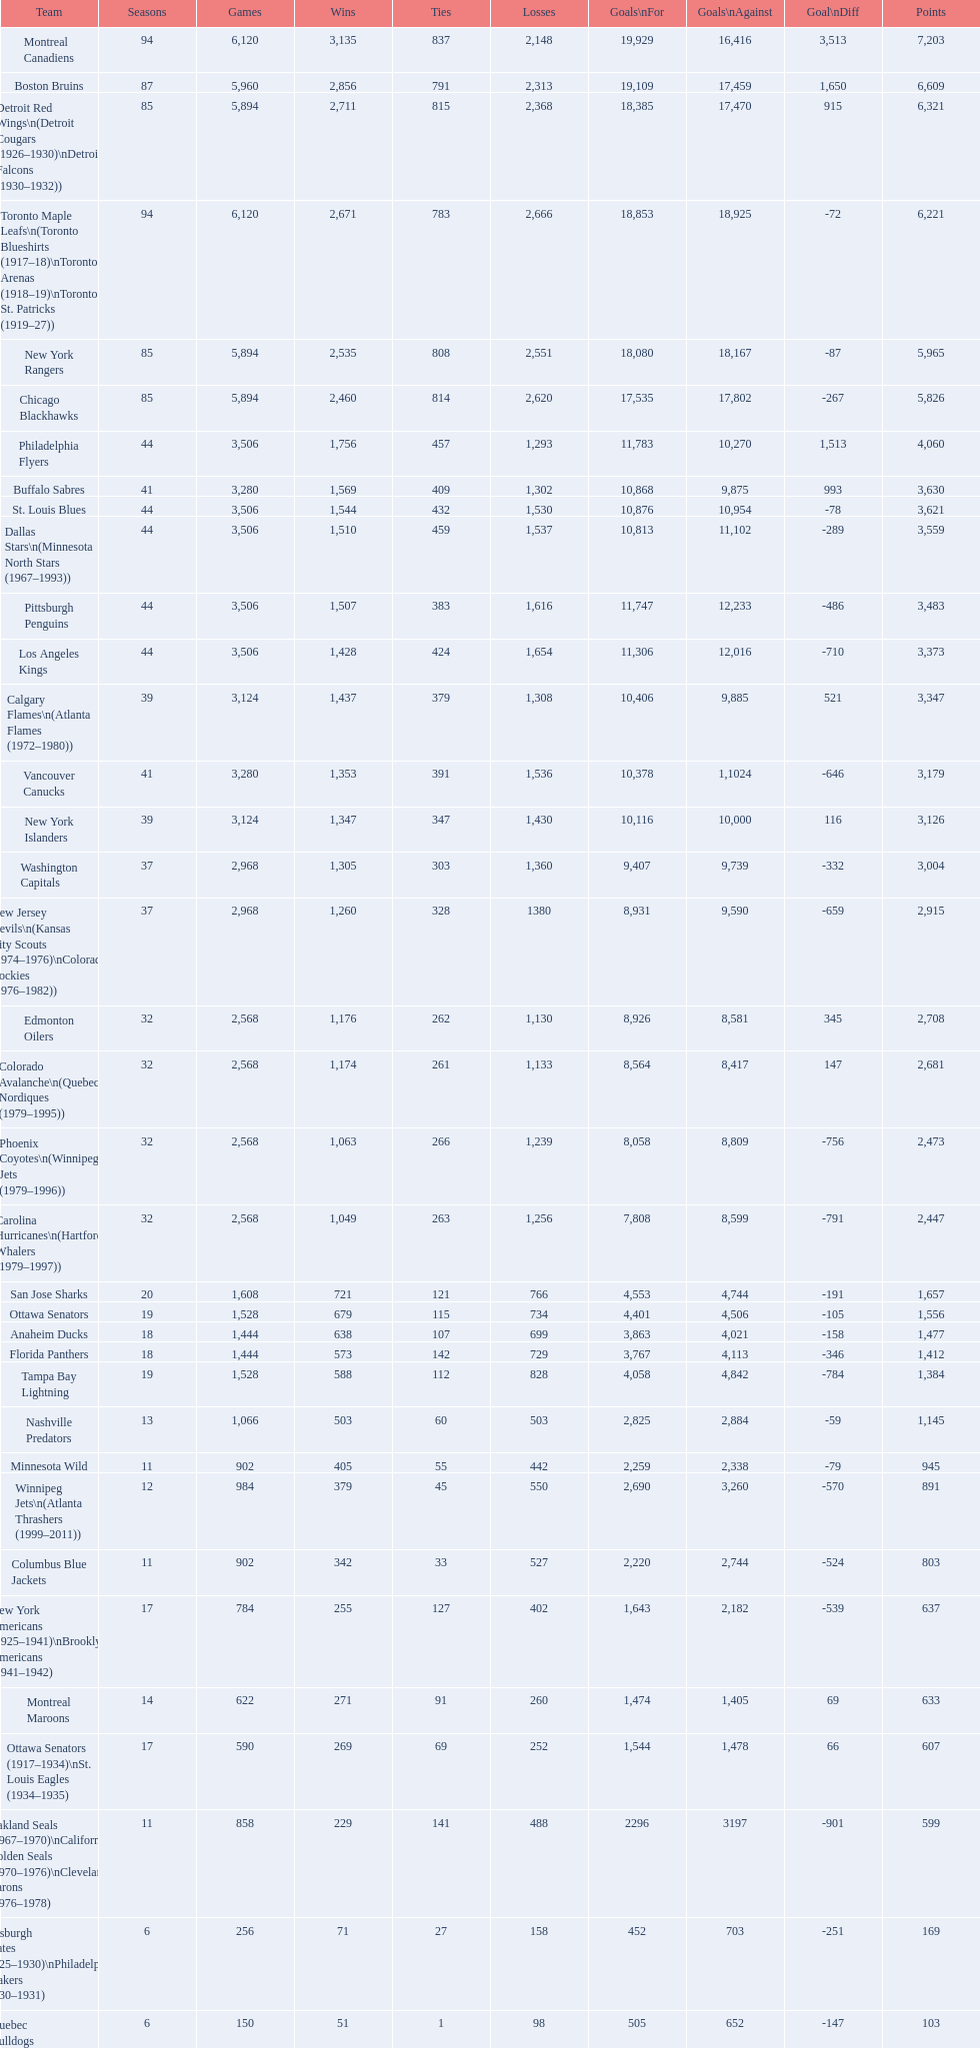What is the number of games that the vancouver canucks have won up to this point? 1,353. 